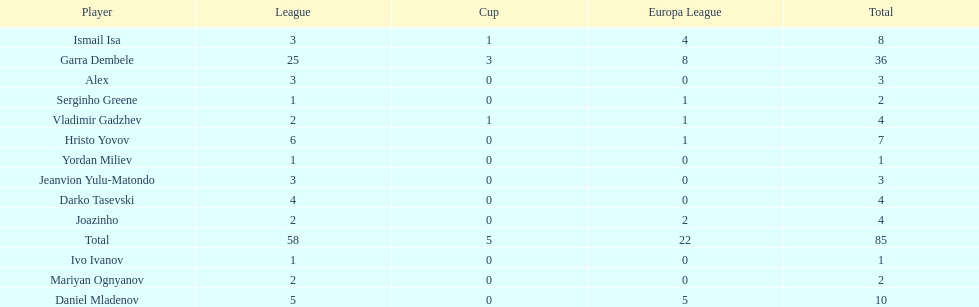What is the difference between vladimir gadzhev and yordan miliev's scores? 3. 